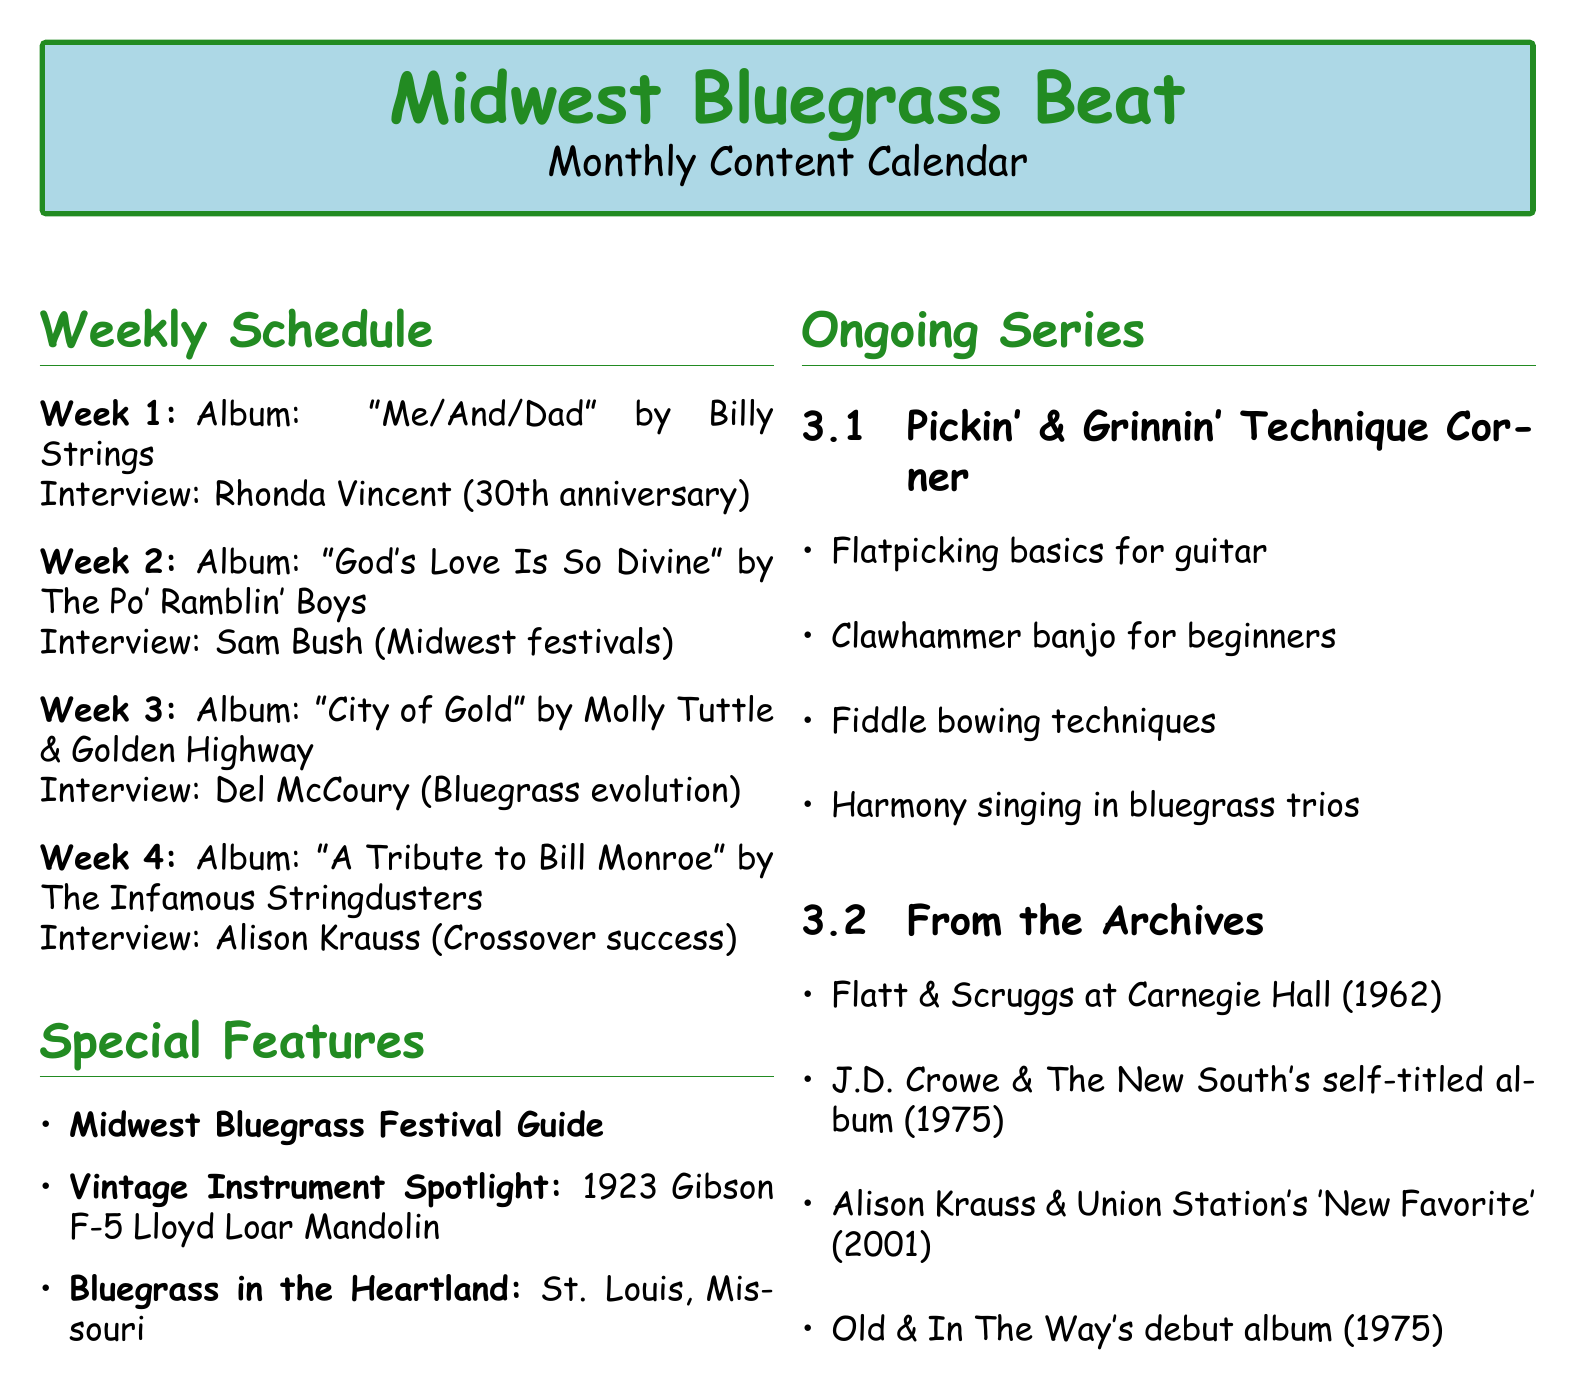What is the title of the blog? The title of the blog is mentioned at the top of the document.
Answer: Midwest Bluegrass Beat Who is the artist of the album reviewed in Week 3? The artist is specified in the album review section for Week 3.
Answer: Molly Tuttle & Golden Highway What is the release date of "God's Love Is So Divine"? The release date is provided in the album review for Week 2.
Answer: 2023-05-12 Which special feature focuses on classic bluegrass instruments? The document lists individual special features, one of which pertains to instruments.
Answer: Vintage Instrument Spotlight What is the focus of the interview with Rhonda Vincent? The focus of the interview is outlined in the artist interview section for Week 1.
Answer: 30th anniversary of her solo career How many weeks are there in the monthly content calendar? The number of weeks can be determined by counting the listed weeks in the schedule section.
Answer: 4 Which city is featured in the "Bluegrass in the Heartland" special feature? This information is contained in the description of the special feature.
Answer: St. Louis, Missouri What is the title of the album reviewed in Week 4? The title is stated in the album review section for Week 4.
Answer: A Tribute to Bill Monroe 